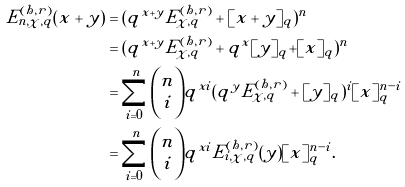<formula> <loc_0><loc_0><loc_500><loc_500>E _ { n , \chi , q } ^ { ( h , r ) } ( x + y ) & = ( q ^ { x + y } E _ { \chi , q } ^ { ( h , r ) } + [ x + y ] _ { q } ) ^ { n } \\ & = ( q ^ { x + y } E _ { \chi , q } ^ { ( h , r ) } + q ^ { x } [ y ] _ { q } + [ x ] _ { q } ) ^ { n } \\ & = \sum _ { i = 0 } ^ { n } { { n } \choose { i } } q ^ { x i } ( q ^ { y } E _ { \chi , q } ^ { ( h , r ) } + [ y ] _ { q } ) ^ { i } [ x ] _ { q } ^ { n - i } \\ & = \sum _ { i = 0 } ^ { n } { { n } \choose { i } } q ^ { x i } E _ { i , \chi , q } ^ { ( h , r ) } ( y ) [ x ] _ { q } ^ { n - i } . \\</formula> 